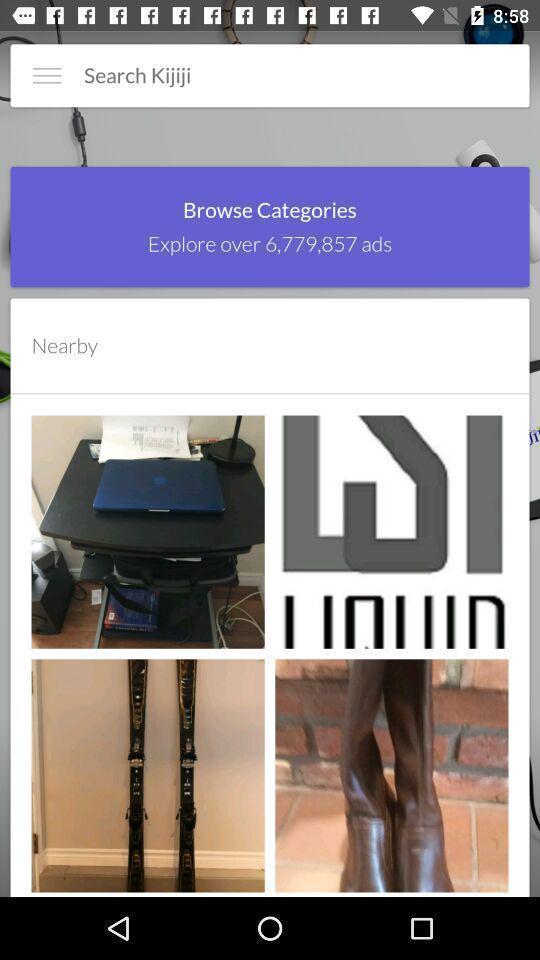Describe the key features of this screenshot. Search page of the app. 